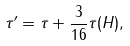<formula> <loc_0><loc_0><loc_500><loc_500>\tau ^ { \prime } = \tau + \frac { 3 } { 1 6 } \tau ( H ) ,</formula> 